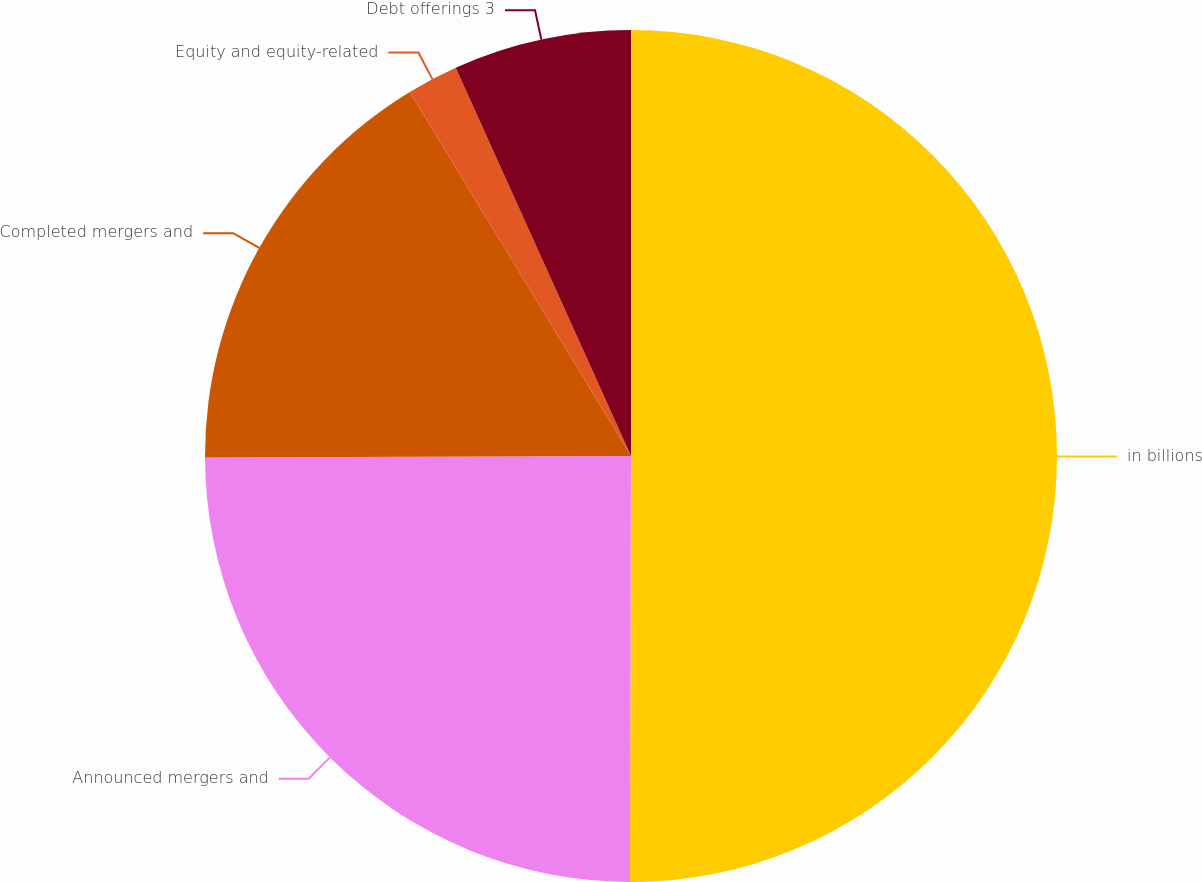Convert chart to OTSL. <chart><loc_0><loc_0><loc_500><loc_500><pie_chart><fcel>in billions<fcel>Announced mergers and<fcel>Completed mergers and<fcel>Equity and equity-related<fcel>Debt offerings 3<nl><fcel>50.04%<fcel>24.9%<fcel>16.37%<fcel>1.94%<fcel>6.75%<nl></chart> 